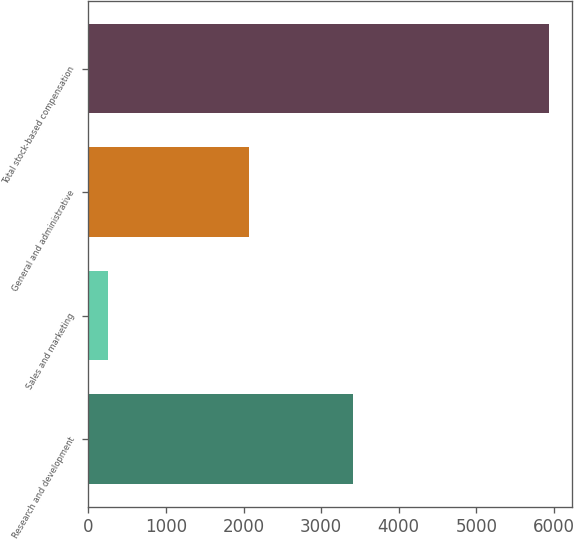Convert chart. <chart><loc_0><loc_0><loc_500><loc_500><bar_chart><fcel>Research and development<fcel>Sales and marketing<fcel>General and administrative<fcel>Total stock-based compensation<nl><fcel>3409<fcel>249<fcel>2073<fcel>5931<nl></chart> 